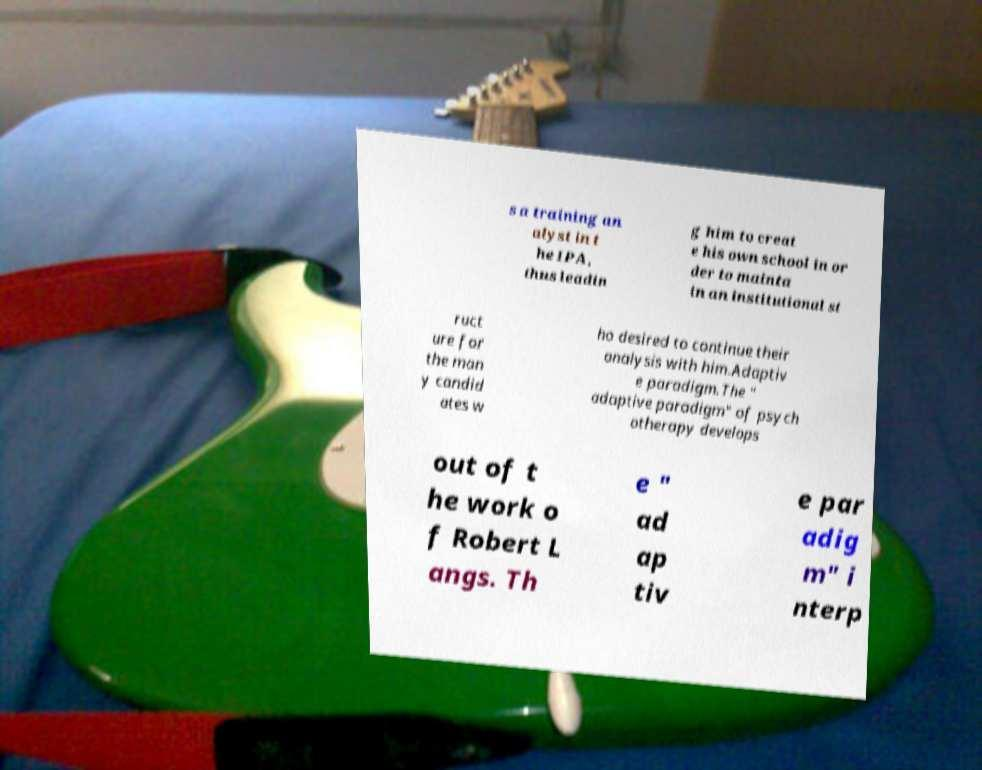Could you extract and type out the text from this image? s a training an alyst in t he IPA, thus leadin g him to creat e his own school in or der to mainta in an institutional st ruct ure for the man y candid ates w ho desired to continue their analysis with him.Adaptiv e paradigm.The " adaptive paradigm" of psych otherapy develops out of t he work o f Robert L angs. Th e " ad ap tiv e par adig m" i nterp 